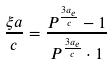<formula> <loc_0><loc_0><loc_500><loc_500>\frac { \xi a } { c } = \frac { P ^ { \frac { 3 a _ { e } } { c } } - 1 } { P ^ { \frac { 3 a _ { e } } { c } } \cdot 1 }</formula> 